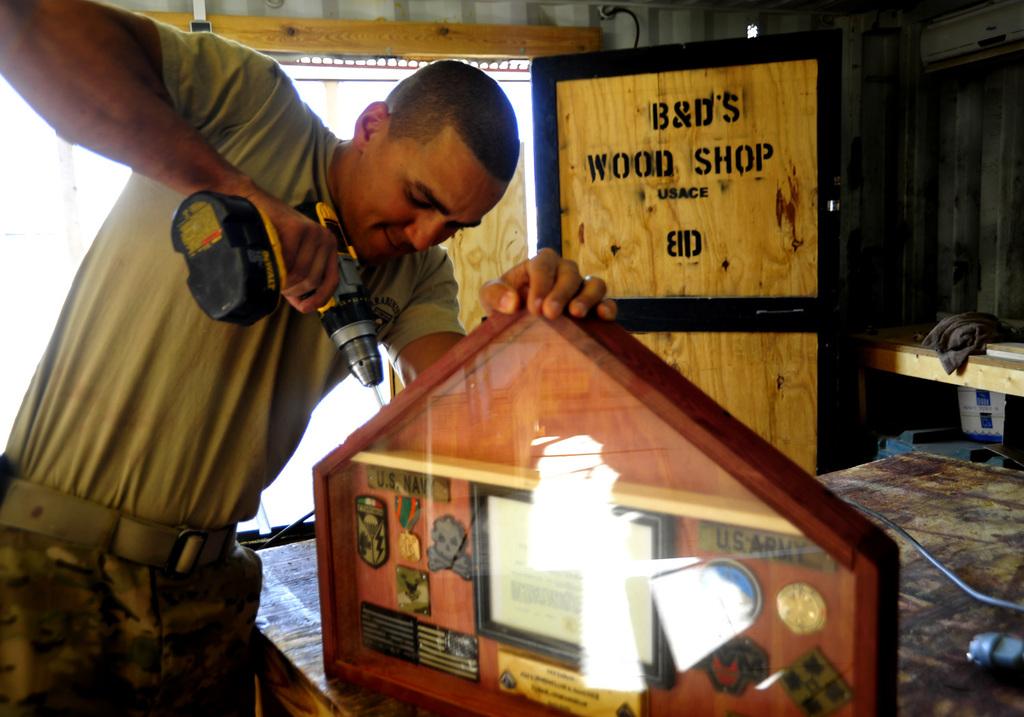What is the name of this place?
Your response must be concise. B&d's wood shop. What kind of place is this?
Provide a short and direct response. Wood shop. 